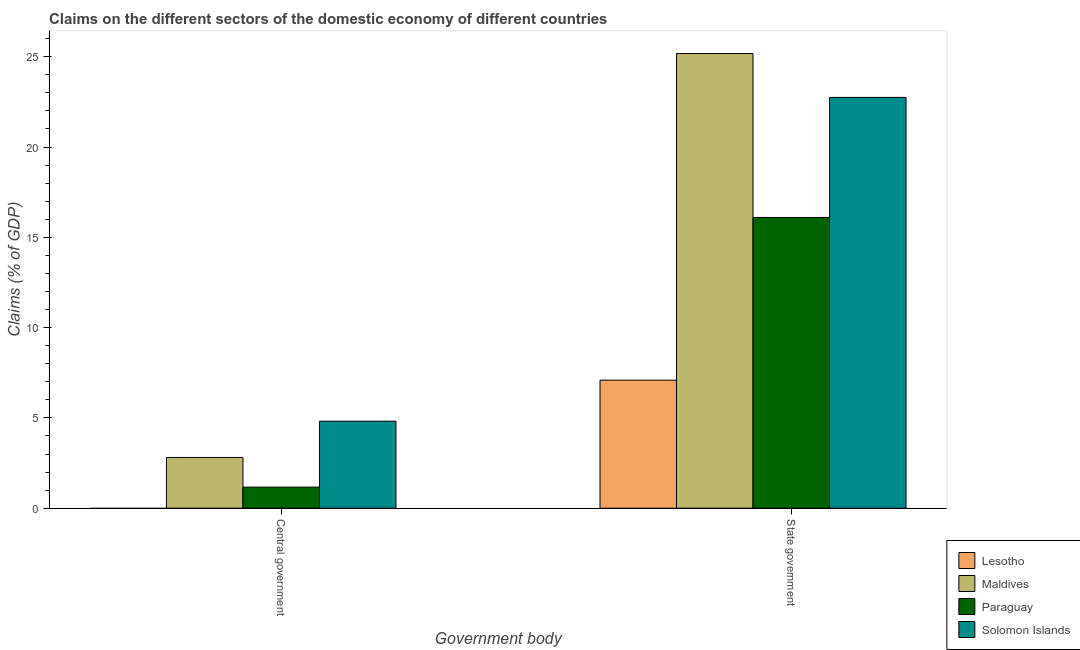How many different coloured bars are there?
Your answer should be very brief. 4. Are the number of bars per tick equal to the number of legend labels?
Your answer should be very brief. No. Are the number of bars on each tick of the X-axis equal?
Your answer should be compact. No. How many bars are there on the 1st tick from the right?
Your response must be concise. 4. What is the label of the 1st group of bars from the left?
Offer a terse response. Central government. What is the claims on state government in Paraguay?
Give a very brief answer. 16.1. Across all countries, what is the maximum claims on central government?
Offer a very short reply. 4.82. Across all countries, what is the minimum claims on central government?
Your answer should be very brief. 0. In which country was the claims on state government maximum?
Ensure brevity in your answer.  Maldives. What is the total claims on central government in the graph?
Offer a very short reply. 8.79. What is the difference between the claims on state government in Solomon Islands and that in Paraguay?
Provide a short and direct response. 6.65. What is the difference between the claims on state government in Maldives and the claims on central government in Paraguay?
Offer a terse response. 24.01. What is the average claims on central government per country?
Keep it short and to the point. 2.2. What is the difference between the claims on state government and claims on central government in Maldives?
Offer a very short reply. 22.37. What is the ratio of the claims on state government in Solomon Islands to that in Maldives?
Provide a short and direct response. 0.9. How many bars are there?
Offer a very short reply. 7. How many countries are there in the graph?
Make the answer very short. 4. What is the difference between two consecutive major ticks on the Y-axis?
Offer a very short reply. 5. Where does the legend appear in the graph?
Provide a succinct answer. Bottom right. How many legend labels are there?
Offer a terse response. 4. What is the title of the graph?
Give a very brief answer. Claims on the different sectors of the domestic economy of different countries. What is the label or title of the X-axis?
Your answer should be compact. Government body. What is the label or title of the Y-axis?
Provide a short and direct response. Claims (% of GDP). What is the Claims (% of GDP) in Maldives in Central government?
Offer a very short reply. 2.81. What is the Claims (% of GDP) of Paraguay in Central government?
Ensure brevity in your answer.  1.17. What is the Claims (% of GDP) in Solomon Islands in Central government?
Provide a succinct answer. 4.82. What is the Claims (% of GDP) of Lesotho in State government?
Your answer should be compact. 7.09. What is the Claims (% of GDP) in Maldives in State government?
Your answer should be compact. 25.18. What is the Claims (% of GDP) of Paraguay in State government?
Offer a very short reply. 16.1. What is the Claims (% of GDP) of Solomon Islands in State government?
Ensure brevity in your answer.  22.75. Across all Government body, what is the maximum Claims (% of GDP) of Lesotho?
Your answer should be compact. 7.09. Across all Government body, what is the maximum Claims (% of GDP) of Maldives?
Your answer should be compact. 25.18. Across all Government body, what is the maximum Claims (% of GDP) in Paraguay?
Offer a very short reply. 16.1. Across all Government body, what is the maximum Claims (% of GDP) of Solomon Islands?
Ensure brevity in your answer.  22.75. Across all Government body, what is the minimum Claims (% of GDP) in Maldives?
Ensure brevity in your answer.  2.81. Across all Government body, what is the minimum Claims (% of GDP) of Paraguay?
Provide a succinct answer. 1.17. Across all Government body, what is the minimum Claims (% of GDP) of Solomon Islands?
Provide a short and direct response. 4.82. What is the total Claims (% of GDP) in Lesotho in the graph?
Your answer should be compact. 7.09. What is the total Claims (% of GDP) in Maldives in the graph?
Make the answer very short. 27.99. What is the total Claims (% of GDP) in Paraguay in the graph?
Your response must be concise. 17.26. What is the total Claims (% of GDP) in Solomon Islands in the graph?
Make the answer very short. 27.57. What is the difference between the Claims (% of GDP) of Maldives in Central government and that in State government?
Make the answer very short. -22.37. What is the difference between the Claims (% of GDP) of Paraguay in Central government and that in State government?
Your response must be concise. -14.93. What is the difference between the Claims (% of GDP) of Solomon Islands in Central government and that in State government?
Your answer should be compact. -17.93. What is the difference between the Claims (% of GDP) of Maldives in Central government and the Claims (% of GDP) of Paraguay in State government?
Keep it short and to the point. -13.29. What is the difference between the Claims (% of GDP) in Maldives in Central government and the Claims (% of GDP) in Solomon Islands in State government?
Give a very brief answer. -19.94. What is the difference between the Claims (% of GDP) in Paraguay in Central government and the Claims (% of GDP) in Solomon Islands in State government?
Make the answer very short. -21.58. What is the average Claims (% of GDP) in Lesotho per Government body?
Your answer should be compact. 3.54. What is the average Claims (% of GDP) of Maldives per Government body?
Provide a short and direct response. 13.99. What is the average Claims (% of GDP) of Paraguay per Government body?
Give a very brief answer. 8.63. What is the average Claims (% of GDP) in Solomon Islands per Government body?
Offer a terse response. 13.78. What is the difference between the Claims (% of GDP) of Maldives and Claims (% of GDP) of Paraguay in Central government?
Offer a very short reply. 1.64. What is the difference between the Claims (% of GDP) of Maldives and Claims (% of GDP) of Solomon Islands in Central government?
Offer a terse response. -2.01. What is the difference between the Claims (% of GDP) of Paraguay and Claims (% of GDP) of Solomon Islands in Central government?
Make the answer very short. -3.65. What is the difference between the Claims (% of GDP) in Lesotho and Claims (% of GDP) in Maldives in State government?
Provide a succinct answer. -18.09. What is the difference between the Claims (% of GDP) of Lesotho and Claims (% of GDP) of Paraguay in State government?
Give a very brief answer. -9.01. What is the difference between the Claims (% of GDP) in Lesotho and Claims (% of GDP) in Solomon Islands in State government?
Your response must be concise. -15.66. What is the difference between the Claims (% of GDP) of Maldives and Claims (% of GDP) of Paraguay in State government?
Give a very brief answer. 9.08. What is the difference between the Claims (% of GDP) in Maldives and Claims (% of GDP) in Solomon Islands in State government?
Your answer should be compact. 2.43. What is the difference between the Claims (% of GDP) of Paraguay and Claims (% of GDP) of Solomon Islands in State government?
Your response must be concise. -6.65. What is the ratio of the Claims (% of GDP) in Maldives in Central government to that in State government?
Your answer should be very brief. 0.11. What is the ratio of the Claims (% of GDP) in Paraguay in Central government to that in State government?
Make the answer very short. 0.07. What is the ratio of the Claims (% of GDP) in Solomon Islands in Central government to that in State government?
Your answer should be compact. 0.21. What is the difference between the highest and the second highest Claims (% of GDP) in Maldives?
Provide a short and direct response. 22.37. What is the difference between the highest and the second highest Claims (% of GDP) in Paraguay?
Your answer should be very brief. 14.93. What is the difference between the highest and the second highest Claims (% of GDP) in Solomon Islands?
Provide a succinct answer. 17.93. What is the difference between the highest and the lowest Claims (% of GDP) of Lesotho?
Your answer should be compact. 7.09. What is the difference between the highest and the lowest Claims (% of GDP) in Maldives?
Your response must be concise. 22.37. What is the difference between the highest and the lowest Claims (% of GDP) of Paraguay?
Give a very brief answer. 14.93. What is the difference between the highest and the lowest Claims (% of GDP) in Solomon Islands?
Provide a short and direct response. 17.93. 